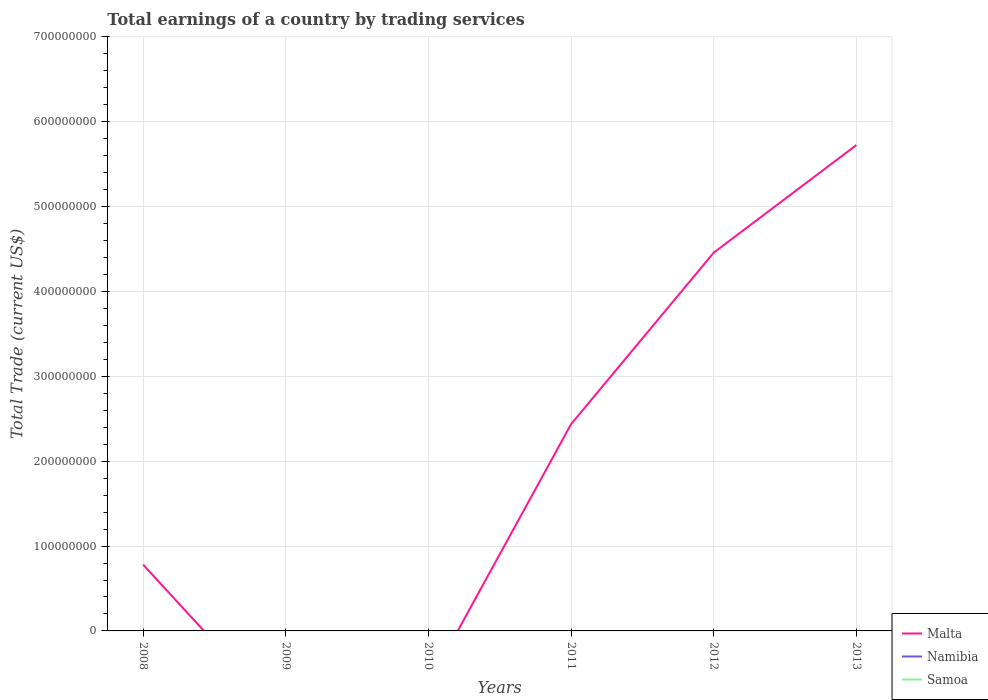How many different coloured lines are there?
Provide a succinct answer. 1. Does the line corresponding to Malta intersect with the line corresponding to Namibia?
Offer a terse response. No. Across all years, what is the maximum total earnings in Samoa?
Provide a succinct answer. 0. What is the total total earnings in Malta in the graph?
Your answer should be very brief. -3.68e+08. What is the difference between the highest and the second highest total earnings in Malta?
Provide a succinct answer. 5.73e+08. Is the total earnings in Malta strictly greater than the total earnings in Namibia over the years?
Make the answer very short. No. Does the graph contain any zero values?
Provide a succinct answer. Yes. Where does the legend appear in the graph?
Keep it short and to the point. Bottom right. How many legend labels are there?
Provide a short and direct response. 3. How are the legend labels stacked?
Your response must be concise. Vertical. What is the title of the graph?
Provide a succinct answer. Total earnings of a country by trading services. What is the label or title of the X-axis?
Your answer should be very brief. Years. What is the label or title of the Y-axis?
Your answer should be very brief. Total Trade (current US$). What is the Total Trade (current US$) of Malta in 2008?
Provide a succinct answer. 7.81e+07. What is the Total Trade (current US$) in Namibia in 2008?
Offer a very short reply. 0. What is the Total Trade (current US$) of Samoa in 2008?
Keep it short and to the point. 0. What is the Total Trade (current US$) in Namibia in 2009?
Keep it short and to the point. 0. What is the Total Trade (current US$) in Malta in 2010?
Provide a succinct answer. 0. What is the Total Trade (current US$) in Namibia in 2010?
Ensure brevity in your answer.  0. What is the Total Trade (current US$) of Samoa in 2010?
Your response must be concise. 0. What is the Total Trade (current US$) of Malta in 2011?
Keep it short and to the point. 2.44e+08. What is the Total Trade (current US$) of Namibia in 2011?
Your response must be concise. 0. What is the Total Trade (current US$) of Malta in 2012?
Offer a very short reply. 4.46e+08. What is the Total Trade (current US$) in Namibia in 2012?
Your answer should be very brief. 0. What is the Total Trade (current US$) of Malta in 2013?
Offer a terse response. 5.73e+08. What is the Total Trade (current US$) in Namibia in 2013?
Make the answer very short. 0. Across all years, what is the maximum Total Trade (current US$) in Malta?
Ensure brevity in your answer.  5.73e+08. What is the total Total Trade (current US$) in Malta in the graph?
Offer a terse response. 1.34e+09. What is the total Total Trade (current US$) of Namibia in the graph?
Ensure brevity in your answer.  0. What is the total Total Trade (current US$) of Samoa in the graph?
Your answer should be compact. 0. What is the difference between the Total Trade (current US$) in Malta in 2008 and that in 2011?
Keep it short and to the point. -1.66e+08. What is the difference between the Total Trade (current US$) of Malta in 2008 and that in 2012?
Offer a very short reply. -3.68e+08. What is the difference between the Total Trade (current US$) in Malta in 2008 and that in 2013?
Ensure brevity in your answer.  -4.94e+08. What is the difference between the Total Trade (current US$) in Malta in 2011 and that in 2012?
Offer a very short reply. -2.02e+08. What is the difference between the Total Trade (current US$) in Malta in 2011 and that in 2013?
Your answer should be compact. -3.29e+08. What is the difference between the Total Trade (current US$) in Malta in 2012 and that in 2013?
Your response must be concise. -1.27e+08. What is the average Total Trade (current US$) in Malta per year?
Ensure brevity in your answer.  2.23e+08. What is the average Total Trade (current US$) in Namibia per year?
Offer a very short reply. 0. What is the ratio of the Total Trade (current US$) of Malta in 2008 to that in 2011?
Your response must be concise. 0.32. What is the ratio of the Total Trade (current US$) of Malta in 2008 to that in 2012?
Make the answer very short. 0.18. What is the ratio of the Total Trade (current US$) of Malta in 2008 to that in 2013?
Provide a short and direct response. 0.14. What is the ratio of the Total Trade (current US$) of Malta in 2011 to that in 2012?
Make the answer very short. 0.55. What is the ratio of the Total Trade (current US$) in Malta in 2011 to that in 2013?
Offer a terse response. 0.43. What is the ratio of the Total Trade (current US$) in Malta in 2012 to that in 2013?
Offer a terse response. 0.78. What is the difference between the highest and the second highest Total Trade (current US$) in Malta?
Provide a succinct answer. 1.27e+08. What is the difference between the highest and the lowest Total Trade (current US$) of Malta?
Ensure brevity in your answer.  5.73e+08. 